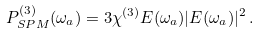<formula> <loc_0><loc_0><loc_500><loc_500>P ^ { ( 3 ) } _ { S P M } ( \omega _ { a } ) = 3 \chi ^ { ( 3 ) } E ( \omega _ { a } ) | E ( \omega _ { a } ) | ^ { 2 } \, .</formula> 